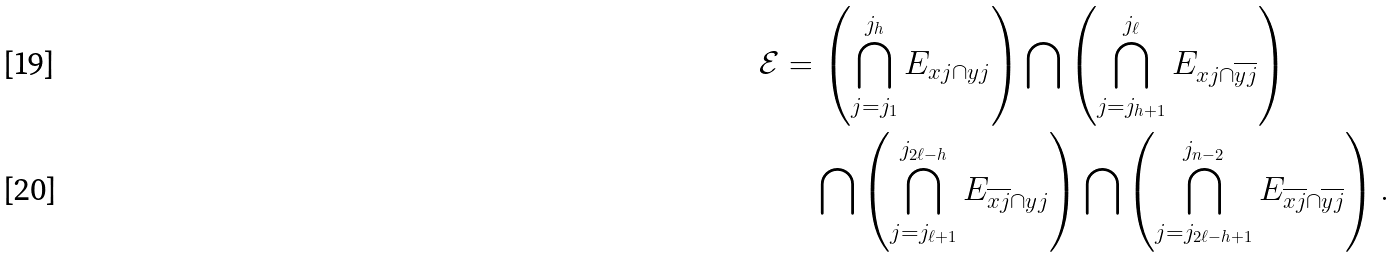Convert formula to latex. <formula><loc_0><loc_0><loc_500><loc_500>\mathcal { E } & = \left ( \bigcap _ { j = j _ { 1 } } ^ { j _ { h } } E _ { { x } j \cap { y } j } \right ) \bigcap \left ( \bigcap _ { j = j _ { h + 1 } } ^ { j _ { \ell } } E _ { { x } j \cap \overline { { { y } j } } } \right ) \\ & \quad \bigcap \left ( \bigcap _ { j = { j _ { \ell + 1 } } } ^ { { j _ { 2 \ell - h } } } E _ { \overline { { x } j } \cap { y } j } \right ) \bigcap \left ( \bigcap _ { j = { j _ { 2 \ell - h + 1 } } } ^ { { j _ { n - 2 } } } E _ { \overline { { x } j } \cap \overline { y j } } \right ) .</formula> 